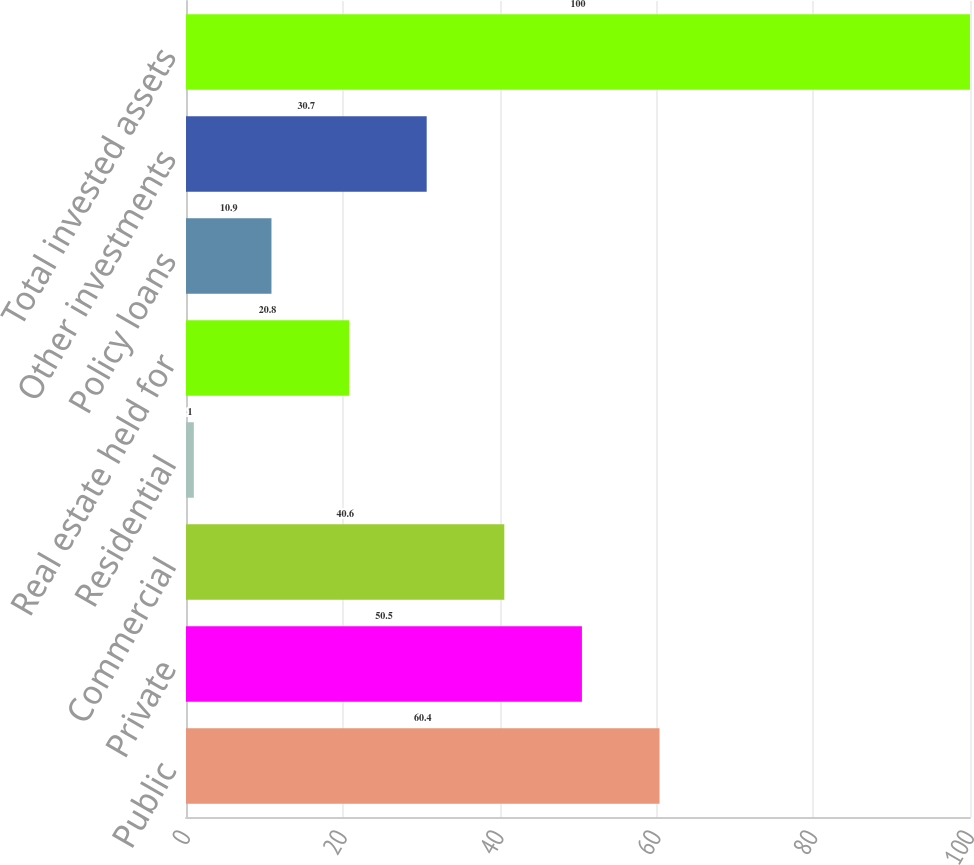<chart> <loc_0><loc_0><loc_500><loc_500><bar_chart><fcel>Public<fcel>Private<fcel>Commercial<fcel>Residential<fcel>Real estate held for<fcel>Policy loans<fcel>Other investments<fcel>Total invested assets<nl><fcel>60.4<fcel>50.5<fcel>40.6<fcel>1<fcel>20.8<fcel>10.9<fcel>30.7<fcel>100<nl></chart> 